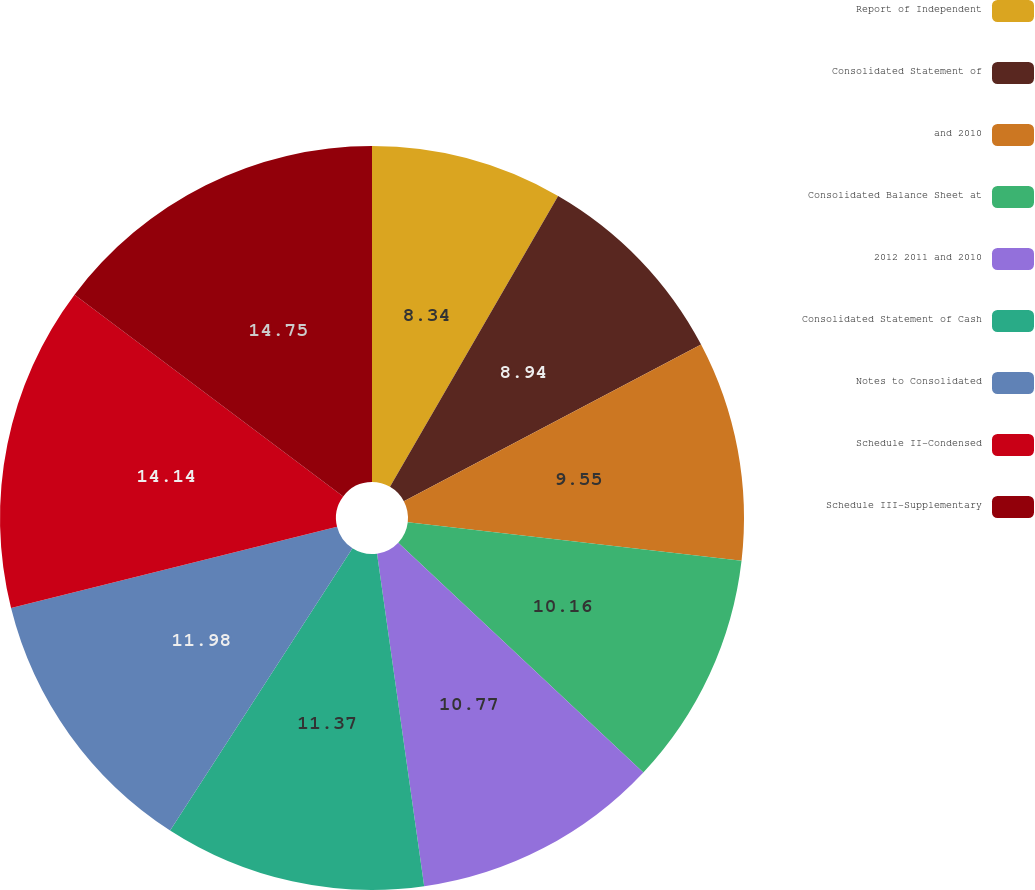Convert chart to OTSL. <chart><loc_0><loc_0><loc_500><loc_500><pie_chart><fcel>Report of Independent<fcel>Consolidated Statement of<fcel>and 2010<fcel>Consolidated Balance Sheet at<fcel>2012 2011 and 2010<fcel>Consolidated Statement of Cash<fcel>Notes to Consolidated<fcel>Schedule II-Condensed<fcel>Schedule III-Supplementary<nl><fcel>8.34%<fcel>8.94%<fcel>9.55%<fcel>10.16%<fcel>10.77%<fcel>11.37%<fcel>11.98%<fcel>14.14%<fcel>14.75%<nl></chart> 